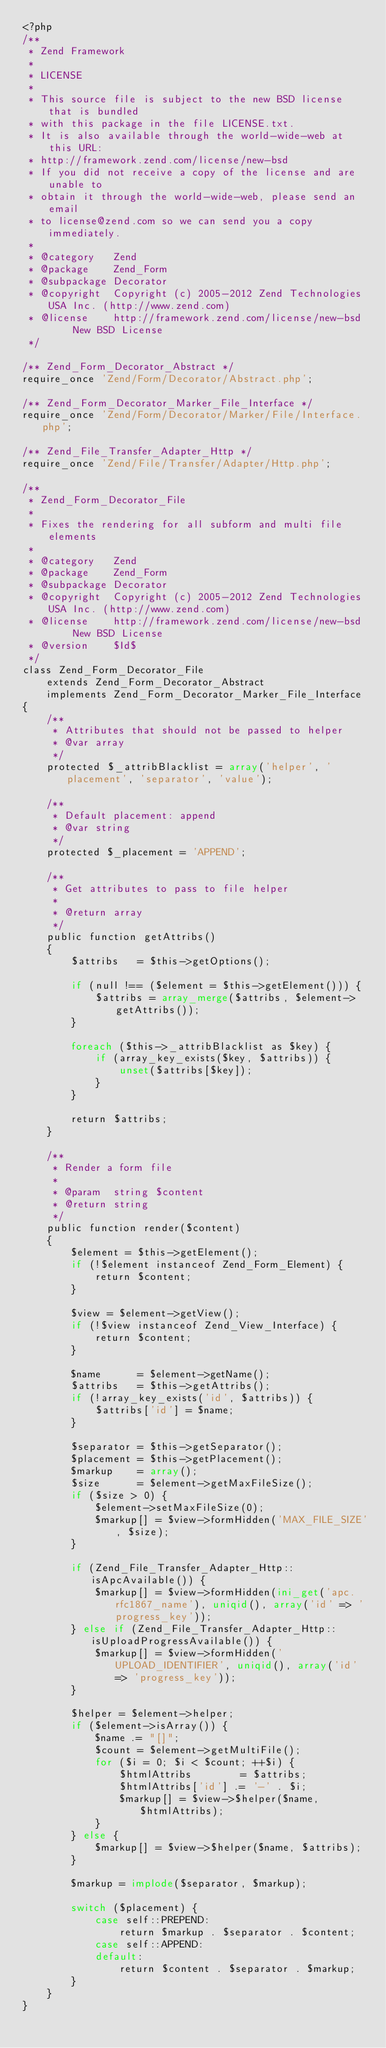<code> <loc_0><loc_0><loc_500><loc_500><_PHP_><?php
/**
 * Zend Framework
 *
 * LICENSE
 *
 * This source file is subject to the new BSD license that is bundled
 * with this package in the file LICENSE.txt.
 * It is also available through the world-wide-web at this URL:
 * http://framework.zend.com/license/new-bsd
 * If you did not receive a copy of the license and are unable to
 * obtain it through the world-wide-web, please send an email
 * to license@zend.com so we can send you a copy immediately.
 *
 * @category   Zend
 * @package    Zend_Form
 * @subpackage Decorator
 * @copyright  Copyright (c) 2005-2012 Zend Technologies USA Inc. (http://www.zend.com)
 * @license    http://framework.zend.com/license/new-bsd     New BSD License
 */

/** Zend_Form_Decorator_Abstract */
require_once 'Zend/Form/Decorator/Abstract.php';

/** Zend_Form_Decorator_Marker_File_Interface */
require_once 'Zend/Form/Decorator/Marker/File/Interface.php';

/** Zend_File_Transfer_Adapter_Http */
require_once 'Zend/File/Transfer/Adapter/Http.php';

/**
 * Zend_Form_Decorator_File
 *
 * Fixes the rendering for all subform and multi file elements
 *
 * @category   Zend
 * @package    Zend_Form
 * @subpackage Decorator
 * @copyright  Copyright (c) 2005-2012 Zend Technologies USA Inc. (http://www.zend.com)
 * @license    http://framework.zend.com/license/new-bsd     New BSD License
 * @version    $Id$
 */
class Zend_Form_Decorator_File
    extends Zend_Form_Decorator_Abstract
    implements Zend_Form_Decorator_Marker_File_Interface
{
    /**
     * Attributes that should not be passed to helper
     * @var array
     */
    protected $_attribBlacklist = array('helper', 'placement', 'separator', 'value');

    /**
     * Default placement: append
     * @var string
     */
    protected $_placement = 'APPEND';

    /**
     * Get attributes to pass to file helper
     *
     * @return array
     */
    public function getAttribs()
    {
        $attribs   = $this->getOptions();

        if (null !== ($element = $this->getElement())) {
            $attribs = array_merge($attribs, $element->getAttribs());
        }

        foreach ($this->_attribBlacklist as $key) {
            if (array_key_exists($key, $attribs)) {
                unset($attribs[$key]);
            }
        }

        return $attribs;
    }

    /**
     * Render a form file
     *
     * @param  string $content
     * @return string
     */
    public function render($content)
    {
        $element = $this->getElement();
        if (!$element instanceof Zend_Form_Element) {
            return $content;
        }

        $view = $element->getView();
        if (!$view instanceof Zend_View_Interface) {
            return $content;
        }

        $name      = $element->getName();
        $attribs   = $this->getAttribs();
        if (!array_key_exists('id', $attribs)) {
            $attribs['id'] = $name;
        }

        $separator = $this->getSeparator();
        $placement = $this->getPlacement();
        $markup    = array();
        $size      = $element->getMaxFileSize();
        if ($size > 0) {
            $element->setMaxFileSize(0);
            $markup[] = $view->formHidden('MAX_FILE_SIZE', $size);
        }

        if (Zend_File_Transfer_Adapter_Http::isApcAvailable()) {
            $markup[] = $view->formHidden(ini_get('apc.rfc1867_name'), uniqid(), array('id' => 'progress_key'));
        } else if (Zend_File_Transfer_Adapter_Http::isUploadProgressAvailable()) {
            $markup[] = $view->formHidden('UPLOAD_IDENTIFIER', uniqid(), array('id' => 'progress_key'));
        }

        $helper = $element->helper;
        if ($element->isArray()) {
            $name .= "[]";
            $count = $element->getMultiFile();
            for ($i = 0; $i < $count; ++$i) {
                $htmlAttribs        = $attribs;
                $htmlAttribs['id'] .= '-' . $i;
                $markup[] = $view->$helper($name, $htmlAttribs);
            }
        } else {
            $markup[] = $view->$helper($name, $attribs);
        }

        $markup = implode($separator, $markup);

        switch ($placement) {
            case self::PREPEND:
                return $markup . $separator . $content;
            case self::APPEND:
            default:
                return $content . $separator . $markup;
        }
    }
}
</code> 